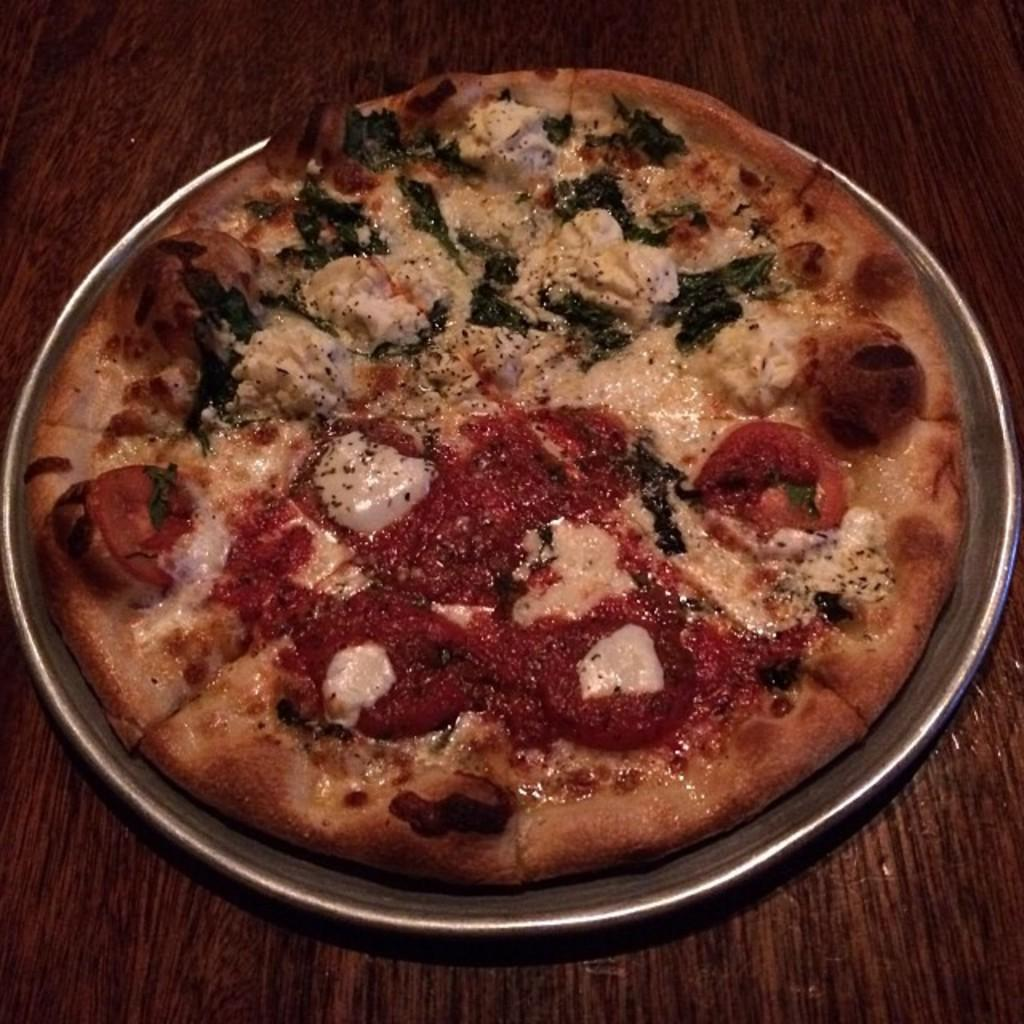What type of food is on the plate in the image? There is a pizza on a plate in the image. Where is the pizza located? The pizza is on a table. What type of border is visible around the pizza in the image? There is no border visible around the pizza in the image. What kind of rock can be seen on the pizza in the image? There is no rock present on the pizza in the image. 